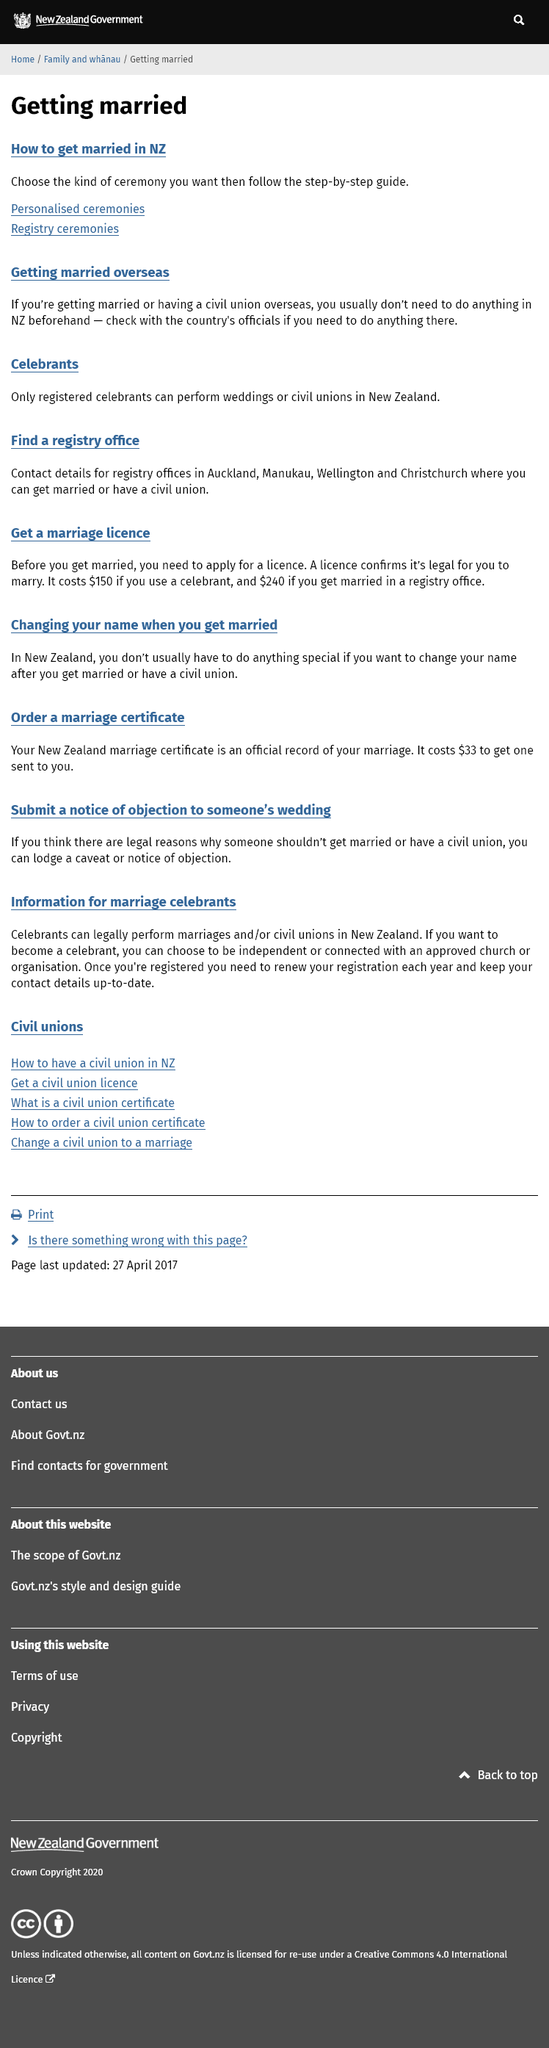Draw attention to some important aspects in this diagram. In New Zealand, there are two types of ceremonies that can be used to get married: a civil ceremony and a religious ceremony. Only a registered celebrant in New Zealand is authorized to perform weddings or civil unions. You can get married or have a civil union in registry offices located in Auckland, Manukau, Wellington, and Christchurch. 